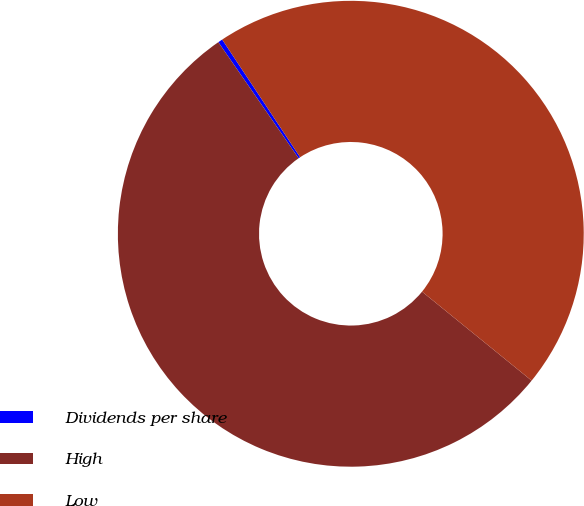Convert chart to OTSL. <chart><loc_0><loc_0><loc_500><loc_500><pie_chart><fcel>Dividends per share<fcel>High<fcel>Low<nl><fcel>0.32%<fcel>54.52%<fcel>45.17%<nl></chart> 